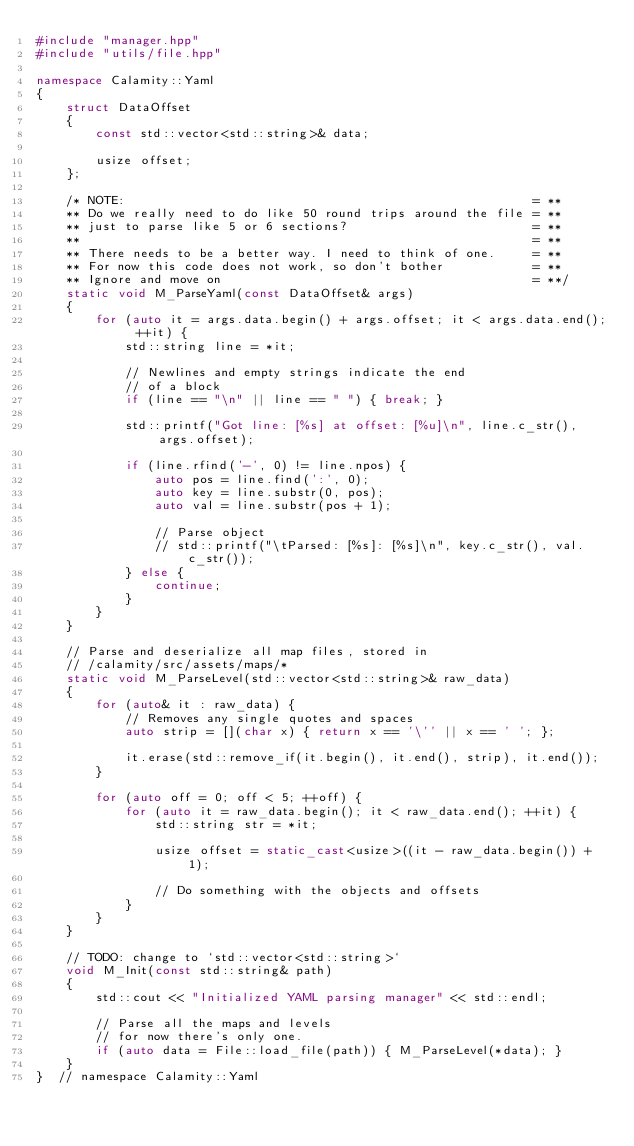Convert code to text. <code><loc_0><loc_0><loc_500><loc_500><_C++_>#include "manager.hpp"
#include "utils/file.hpp"

namespace Calamity::Yaml
{
    struct DataOffset
    {
        const std::vector<std::string>& data;

        usize offset;
    };

    /* NOTE:                                                       = **
    ** Do we really need to do like 50 round trips around the file = **
    ** just to parse like 5 or 6 sections?                         = **
    **                                                             = **
    ** There needs to be a better way. I need to think of one.     = **
    ** For now this code does not work, so don't bother            = **
    ** Ignore and move on                                          = **/
    static void M_ParseYaml(const DataOffset& args)
    {
        for (auto it = args.data.begin() + args.offset; it < args.data.end(); ++it) {
            std::string line = *it;

            // Newlines and empty strings indicate the end
            // of a block
            if (line == "\n" || line == " ") { break; }

            std::printf("Got line: [%s] at offset: [%u]\n", line.c_str(), args.offset);

            if (line.rfind('-', 0) != line.npos) {
                auto pos = line.find(':', 0);
                auto key = line.substr(0, pos);
                auto val = line.substr(pos + 1);

                // Parse object
                // std::printf("\tParsed: [%s]: [%s]\n", key.c_str(), val.c_str());
            } else {
                continue;
            }
        }
    }

    // Parse and deserialize all map files, stored in
    // /calamity/src/assets/maps/*
    static void M_ParseLevel(std::vector<std::string>& raw_data)
    {
        for (auto& it : raw_data) {
            // Removes any single quotes and spaces
            auto strip = [](char x) { return x == '\'' || x == ' '; };

            it.erase(std::remove_if(it.begin(), it.end(), strip), it.end());
        }

        for (auto off = 0; off < 5; ++off) {
            for (auto it = raw_data.begin(); it < raw_data.end(); ++it) {
                std::string str = *it;

                usize offset = static_cast<usize>((it - raw_data.begin()) + 1);

                // Do something with the objects and offsets
            }
        }
    }

    // TODO: change to `std::vector<std::string>`
    void M_Init(const std::string& path)
    {
        std::cout << "Initialized YAML parsing manager" << std::endl;

        // Parse all the maps and levels
        // for now there's only one.
        if (auto data = File::load_file(path)) { M_ParseLevel(*data); }
    }
}  // namespace Calamity::Yaml
</code> 